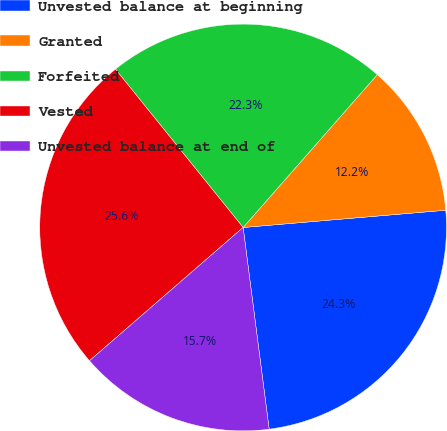Convert chart to OTSL. <chart><loc_0><loc_0><loc_500><loc_500><pie_chart><fcel>Unvested balance at beginning<fcel>Granted<fcel>Forfeited<fcel>Vested<fcel>Unvested balance at end of<nl><fcel>24.31%<fcel>12.18%<fcel>22.27%<fcel>25.57%<fcel>15.67%<nl></chart> 